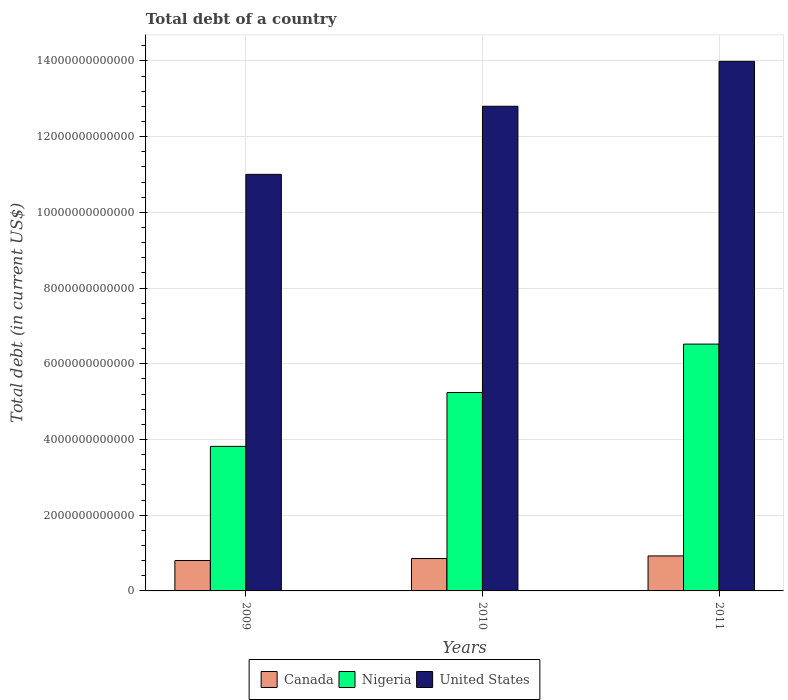How many different coloured bars are there?
Offer a terse response. 3. What is the debt in United States in 2010?
Make the answer very short. 1.28e+13. Across all years, what is the maximum debt in Canada?
Provide a succinct answer. 9.24e+11. Across all years, what is the minimum debt in Nigeria?
Provide a succinct answer. 3.82e+12. In which year was the debt in Nigeria maximum?
Your answer should be compact. 2011. What is the total debt in Nigeria in the graph?
Your answer should be compact. 1.56e+13. What is the difference between the debt in United States in 2009 and that in 2010?
Offer a terse response. -1.80e+12. What is the difference between the debt in United States in 2010 and the debt in Canada in 2009?
Your response must be concise. 1.20e+13. What is the average debt in Nigeria per year?
Give a very brief answer. 5.19e+12. In the year 2011, what is the difference between the debt in Nigeria and debt in United States?
Provide a short and direct response. -7.47e+12. In how many years, is the debt in United States greater than 13200000000000 US$?
Your answer should be compact. 1. What is the ratio of the debt in United States in 2010 to that in 2011?
Offer a very short reply. 0.92. Is the debt in United States in 2009 less than that in 2010?
Ensure brevity in your answer.  Yes. What is the difference between the highest and the second highest debt in Canada?
Your answer should be compact. 6.88e+1. What is the difference between the highest and the lowest debt in United States?
Make the answer very short. 2.98e+12. In how many years, is the debt in United States greater than the average debt in United States taken over all years?
Ensure brevity in your answer.  2. Is the sum of the debt in Canada in 2009 and 2011 greater than the maximum debt in Nigeria across all years?
Your answer should be very brief. No. What does the 2nd bar from the left in 2010 represents?
Keep it short and to the point. Nigeria. Is it the case that in every year, the sum of the debt in Nigeria and debt in Canada is greater than the debt in United States?
Provide a succinct answer. No. What is the difference between two consecutive major ticks on the Y-axis?
Provide a short and direct response. 2.00e+12. Are the values on the major ticks of Y-axis written in scientific E-notation?
Offer a terse response. No. Does the graph contain grids?
Give a very brief answer. Yes. Where does the legend appear in the graph?
Provide a succinct answer. Bottom center. How many legend labels are there?
Your response must be concise. 3. How are the legend labels stacked?
Provide a short and direct response. Horizontal. What is the title of the graph?
Ensure brevity in your answer.  Total debt of a country. Does "Costa Rica" appear as one of the legend labels in the graph?
Offer a very short reply. No. What is the label or title of the Y-axis?
Provide a succinct answer. Total debt (in current US$). What is the Total debt (in current US$) in Canada in 2009?
Provide a short and direct response. 8.04e+11. What is the Total debt (in current US$) of Nigeria in 2009?
Ensure brevity in your answer.  3.82e+12. What is the Total debt (in current US$) of United States in 2009?
Your answer should be compact. 1.10e+13. What is the Total debt (in current US$) of Canada in 2010?
Ensure brevity in your answer.  8.55e+11. What is the Total debt (in current US$) in Nigeria in 2010?
Your answer should be very brief. 5.24e+12. What is the Total debt (in current US$) of United States in 2010?
Your answer should be compact. 1.28e+13. What is the Total debt (in current US$) in Canada in 2011?
Provide a succinct answer. 9.24e+11. What is the Total debt (in current US$) in Nigeria in 2011?
Make the answer very short. 6.52e+12. What is the Total debt (in current US$) in United States in 2011?
Give a very brief answer. 1.40e+13. Across all years, what is the maximum Total debt (in current US$) in Canada?
Offer a terse response. 9.24e+11. Across all years, what is the maximum Total debt (in current US$) in Nigeria?
Keep it short and to the point. 6.52e+12. Across all years, what is the maximum Total debt (in current US$) in United States?
Make the answer very short. 1.40e+13. Across all years, what is the minimum Total debt (in current US$) in Canada?
Provide a short and direct response. 8.04e+11. Across all years, what is the minimum Total debt (in current US$) in Nigeria?
Make the answer very short. 3.82e+12. Across all years, what is the minimum Total debt (in current US$) of United States?
Your response must be concise. 1.10e+13. What is the total Total debt (in current US$) of Canada in the graph?
Offer a terse response. 2.58e+12. What is the total Total debt (in current US$) in Nigeria in the graph?
Ensure brevity in your answer.  1.56e+13. What is the total Total debt (in current US$) in United States in the graph?
Your answer should be very brief. 3.78e+13. What is the difference between the Total debt (in current US$) in Canada in 2009 and that in 2010?
Make the answer very short. -5.16e+1. What is the difference between the Total debt (in current US$) in Nigeria in 2009 and that in 2010?
Offer a very short reply. -1.42e+12. What is the difference between the Total debt (in current US$) in United States in 2009 and that in 2010?
Give a very brief answer. -1.80e+12. What is the difference between the Total debt (in current US$) of Canada in 2009 and that in 2011?
Offer a very short reply. -1.20e+11. What is the difference between the Total debt (in current US$) of Nigeria in 2009 and that in 2011?
Offer a very short reply. -2.70e+12. What is the difference between the Total debt (in current US$) in United States in 2009 and that in 2011?
Offer a terse response. -2.98e+12. What is the difference between the Total debt (in current US$) of Canada in 2010 and that in 2011?
Your answer should be compact. -6.88e+1. What is the difference between the Total debt (in current US$) in Nigeria in 2010 and that in 2011?
Offer a very short reply. -1.28e+12. What is the difference between the Total debt (in current US$) of United States in 2010 and that in 2011?
Make the answer very short. -1.19e+12. What is the difference between the Total debt (in current US$) in Canada in 2009 and the Total debt (in current US$) in Nigeria in 2010?
Make the answer very short. -4.44e+12. What is the difference between the Total debt (in current US$) of Canada in 2009 and the Total debt (in current US$) of United States in 2010?
Provide a succinct answer. -1.20e+13. What is the difference between the Total debt (in current US$) in Nigeria in 2009 and the Total debt (in current US$) in United States in 2010?
Provide a short and direct response. -8.98e+12. What is the difference between the Total debt (in current US$) in Canada in 2009 and the Total debt (in current US$) in Nigeria in 2011?
Your response must be concise. -5.72e+12. What is the difference between the Total debt (in current US$) in Canada in 2009 and the Total debt (in current US$) in United States in 2011?
Your answer should be very brief. -1.32e+13. What is the difference between the Total debt (in current US$) in Nigeria in 2009 and the Total debt (in current US$) in United States in 2011?
Offer a terse response. -1.02e+13. What is the difference between the Total debt (in current US$) in Canada in 2010 and the Total debt (in current US$) in Nigeria in 2011?
Your answer should be compact. -5.66e+12. What is the difference between the Total debt (in current US$) in Canada in 2010 and the Total debt (in current US$) in United States in 2011?
Your answer should be compact. -1.31e+13. What is the difference between the Total debt (in current US$) in Nigeria in 2010 and the Total debt (in current US$) in United States in 2011?
Offer a very short reply. -8.75e+12. What is the average Total debt (in current US$) in Canada per year?
Keep it short and to the point. 8.61e+11. What is the average Total debt (in current US$) in Nigeria per year?
Keep it short and to the point. 5.19e+12. What is the average Total debt (in current US$) of United States per year?
Your answer should be compact. 1.26e+13. In the year 2009, what is the difference between the Total debt (in current US$) in Canada and Total debt (in current US$) in Nigeria?
Provide a short and direct response. -3.01e+12. In the year 2009, what is the difference between the Total debt (in current US$) of Canada and Total debt (in current US$) of United States?
Your response must be concise. -1.02e+13. In the year 2009, what is the difference between the Total debt (in current US$) in Nigeria and Total debt (in current US$) in United States?
Make the answer very short. -7.19e+12. In the year 2010, what is the difference between the Total debt (in current US$) of Canada and Total debt (in current US$) of Nigeria?
Make the answer very short. -4.39e+12. In the year 2010, what is the difference between the Total debt (in current US$) of Canada and Total debt (in current US$) of United States?
Your response must be concise. -1.19e+13. In the year 2010, what is the difference between the Total debt (in current US$) of Nigeria and Total debt (in current US$) of United States?
Make the answer very short. -7.56e+12. In the year 2011, what is the difference between the Total debt (in current US$) in Canada and Total debt (in current US$) in Nigeria?
Keep it short and to the point. -5.60e+12. In the year 2011, what is the difference between the Total debt (in current US$) in Canada and Total debt (in current US$) in United States?
Give a very brief answer. -1.31e+13. In the year 2011, what is the difference between the Total debt (in current US$) of Nigeria and Total debt (in current US$) of United States?
Provide a short and direct response. -7.47e+12. What is the ratio of the Total debt (in current US$) of Canada in 2009 to that in 2010?
Offer a terse response. 0.94. What is the ratio of the Total debt (in current US$) in Nigeria in 2009 to that in 2010?
Offer a terse response. 0.73. What is the ratio of the Total debt (in current US$) of United States in 2009 to that in 2010?
Ensure brevity in your answer.  0.86. What is the ratio of the Total debt (in current US$) in Canada in 2009 to that in 2011?
Offer a very short reply. 0.87. What is the ratio of the Total debt (in current US$) of Nigeria in 2009 to that in 2011?
Provide a short and direct response. 0.59. What is the ratio of the Total debt (in current US$) of United States in 2009 to that in 2011?
Make the answer very short. 0.79. What is the ratio of the Total debt (in current US$) in Canada in 2010 to that in 2011?
Keep it short and to the point. 0.93. What is the ratio of the Total debt (in current US$) in Nigeria in 2010 to that in 2011?
Provide a short and direct response. 0.8. What is the ratio of the Total debt (in current US$) in United States in 2010 to that in 2011?
Your response must be concise. 0.92. What is the difference between the highest and the second highest Total debt (in current US$) of Canada?
Give a very brief answer. 6.88e+1. What is the difference between the highest and the second highest Total debt (in current US$) in Nigeria?
Offer a terse response. 1.28e+12. What is the difference between the highest and the second highest Total debt (in current US$) in United States?
Provide a succinct answer. 1.19e+12. What is the difference between the highest and the lowest Total debt (in current US$) in Canada?
Offer a very short reply. 1.20e+11. What is the difference between the highest and the lowest Total debt (in current US$) of Nigeria?
Provide a succinct answer. 2.70e+12. What is the difference between the highest and the lowest Total debt (in current US$) of United States?
Make the answer very short. 2.98e+12. 